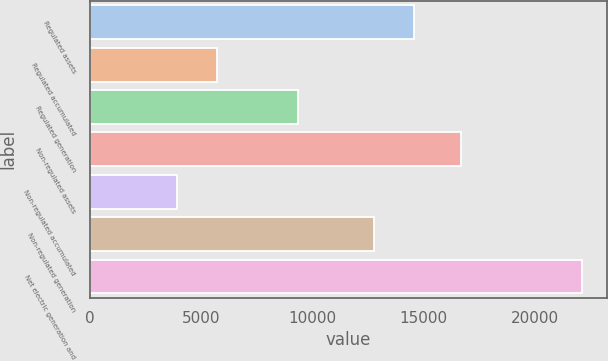<chart> <loc_0><loc_0><loc_500><loc_500><bar_chart><fcel>Regulated assets<fcel>Regulated accumulated<fcel>Regulated generation<fcel>Non-regulated assets<fcel>Non-regulated accumulated<fcel>Non-regulated generation<fcel>Net electric generation and<nl><fcel>14575.9<fcel>5735.9<fcel>9369<fcel>16670<fcel>3915<fcel>12755<fcel>22124<nl></chart> 